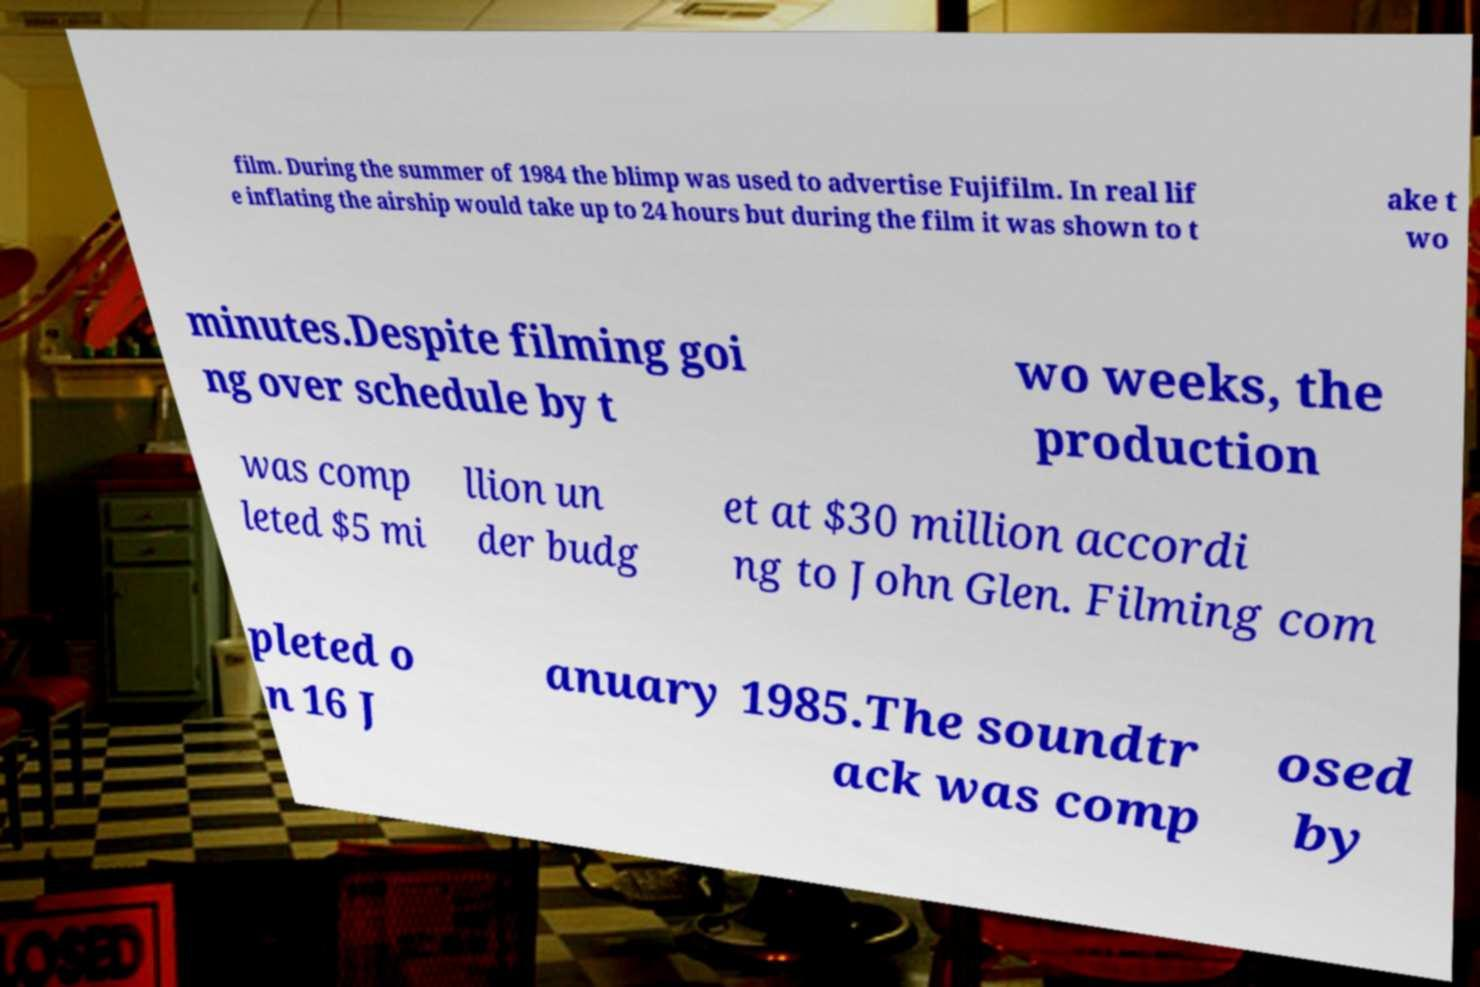Can you read and provide the text displayed in the image?This photo seems to have some interesting text. Can you extract and type it out for me? film. During the summer of 1984 the blimp was used to advertise Fujifilm. In real lif e inflating the airship would take up to 24 hours but during the film it was shown to t ake t wo minutes.Despite filming goi ng over schedule by t wo weeks, the production was comp leted $5 mi llion un der budg et at $30 million accordi ng to John Glen. Filming com pleted o n 16 J anuary 1985.The soundtr ack was comp osed by 